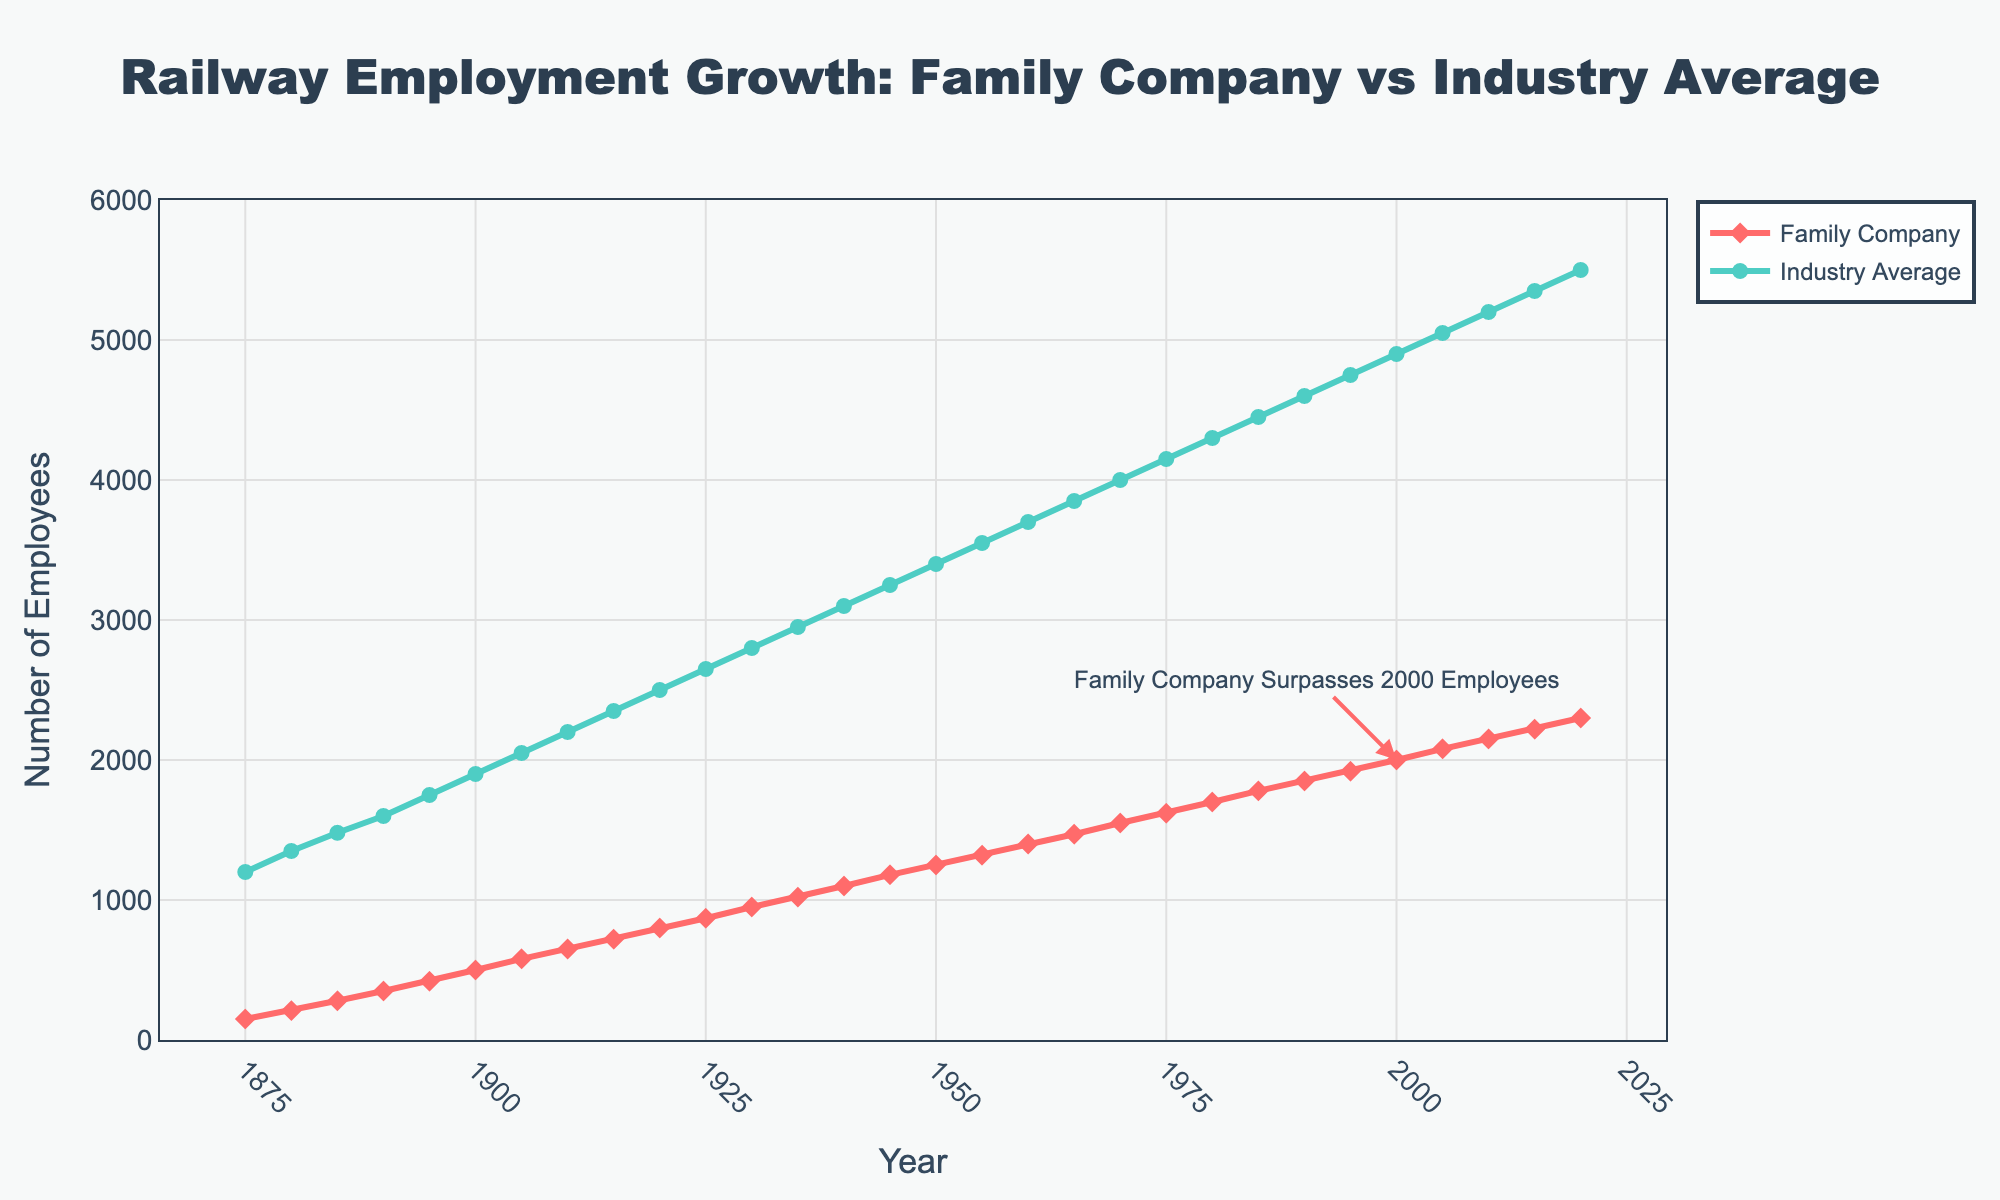What's the difference in the number of employees between the Family Company and the Industry Average in 1920? In 1920, the Family Company has 800 employees, and the Industry Average has 2500 employees. The difference is 2500 - 800 = 1700.
Answer: 1700 When does the Family Company surpass 2000 employees? The annotation in the figure indicates that the Family Company surpasses 2000 employees in the year 2000.
Answer: 2000 How many years did it take for the Family Company to reach 1000 employees since its inception? The Family Company starts in 1875 with 150 employees and reaches 1000 employees in 1935. The time taken is 1935 - 1875 = 60 years.
Answer: 60 years Which year did the Family Company have a higher growth rate compared to the previous data point? Determine the year with the highest increase by comparing the yearly changes; the largest increase is from 1895 to 1900: (500 - 420) = 80 employees.
Answer: 1900 What's the average number of employees in the Family Company from 1875 to 1920? Sum the number of employees for the years 1875, 1880, 1885, 1890, 1895, 1900, 1905, 1910, 1915, and 1920, then divide by the number of years: (150+210+280+350+420+500+580+650+720+800)/10 = 4660/10 = 466.
Answer: 466 By how much did the Industry Average Employment grow between 1980 and 2000? The Industry Average Employment in 1980 is 4300, and in 2000 it is 4900. The growth is 4900 - 4300 = 600 employees.
Answer: 600 In which period did the Family Company see a consistent increase in employment every 5 years? From 1875 to 2020, the Family Company saw a consistent increase in employment every 5 years. Each 5-year interval shows an increase in the number of employees compared to the previous period.
Answer: 1875 to 2020 Which year shows a larger gap between the Family Company Employment and Industry Average Employment, 1880 or 1975? Compare the differences: In 1880, the gap is 1350 - 210 = 1140. In 1975, the gap is 4150 - 1620 = 2530.
Answer: 1975 What's the total increase in employees for the Family Company from 1950 to 2015? Sum the increases for each interval: (1320 - 1250) + (1400 - 1320) + (1470 - 1400) + (1550 - 1470) + (1620 - 1550) + (1700 - 1620) + (1780 - 1700) + (1850 - 1780) + (1920 - 1850) + (2000 - 1920) + (2080 - 2000) + (2150 - 2080) + (2220 - 2150) = 715.
Answer: 715 